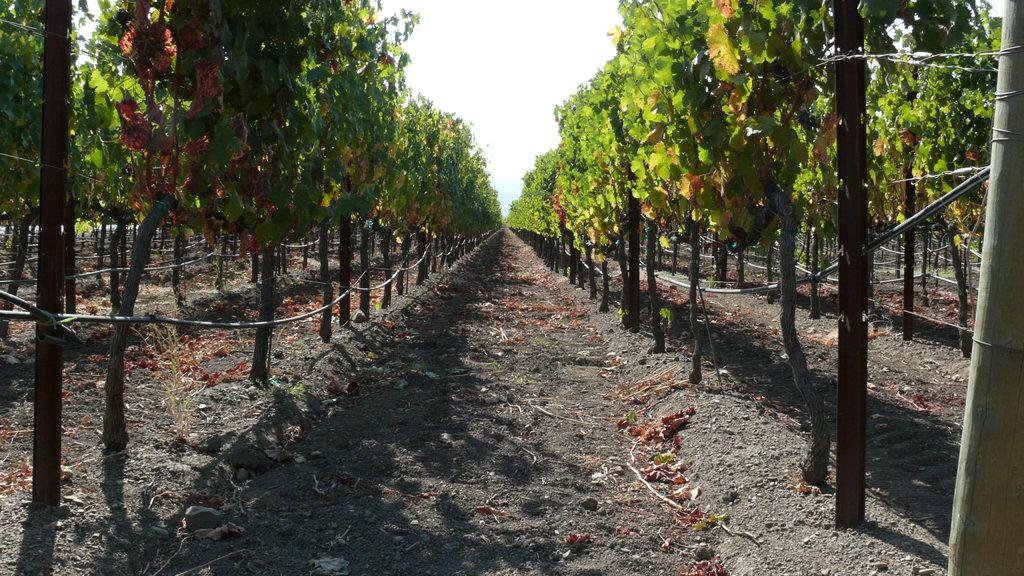What type of vegetation can be seen on the left side of the image? There are trees on the left side of the image. What type of vegetation can be seen on the right side of the image? There are trees on the right side of the image. Can you describe any specific features of the trees in the image? Based on the provided facts, we cannot determine any specific features of the trees in the image. What is the overall setting of the image? The image features trees on both sides, suggesting a natural or outdoor setting. What type of hospital can be seen in the image? There is no hospital present in the image; it features trees on both sides. Can you describe the bird's nest in the image? There is no bird or nest present in the image; it only features trees on both sides. 